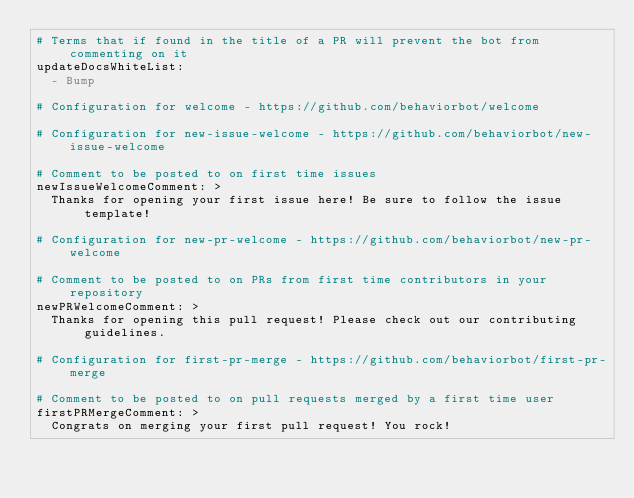Convert code to text. <code><loc_0><loc_0><loc_500><loc_500><_YAML_># Terms that if found in the title of a PR will prevent the bot from commenting on it
updateDocsWhiteList:
  - Bump

# Configuration for welcome - https://github.com/behaviorbot/welcome

# Configuration for new-issue-welcome - https://github.com/behaviorbot/new-issue-welcome

# Comment to be posted to on first time issues
newIssueWelcomeComment: >
  Thanks for opening your first issue here! Be sure to follow the issue template!

# Configuration for new-pr-welcome - https://github.com/behaviorbot/new-pr-welcome

# Comment to be posted to on PRs from first time contributors in your repository
newPRWelcomeComment: >
  Thanks for opening this pull request! Please check out our contributing guidelines.

# Configuration for first-pr-merge - https://github.com/behaviorbot/first-pr-merge

# Comment to be posted to on pull requests merged by a first time user
firstPRMergeComment: >
  Congrats on merging your first pull request! You rock!</code> 